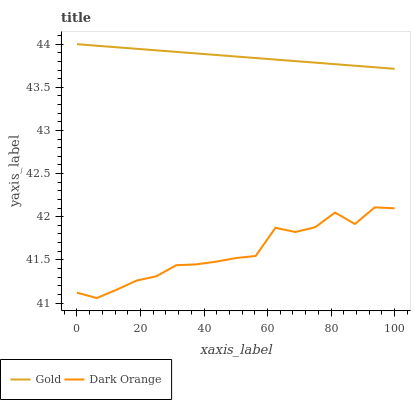Does Gold have the minimum area under the curve?
Answer yes or no. No. Is Gold the roughest?
Answer yes or no. No. Does Gold have the lowest value?
Answer yes or no. No. Is Dark Orange less than Gold?
Answer yes or no. Yes. Is Gold greater than Dark Orange?
Answer yes or no. Yes. Does Dark Orange intersect Gold?
Answer yes or no. No. 